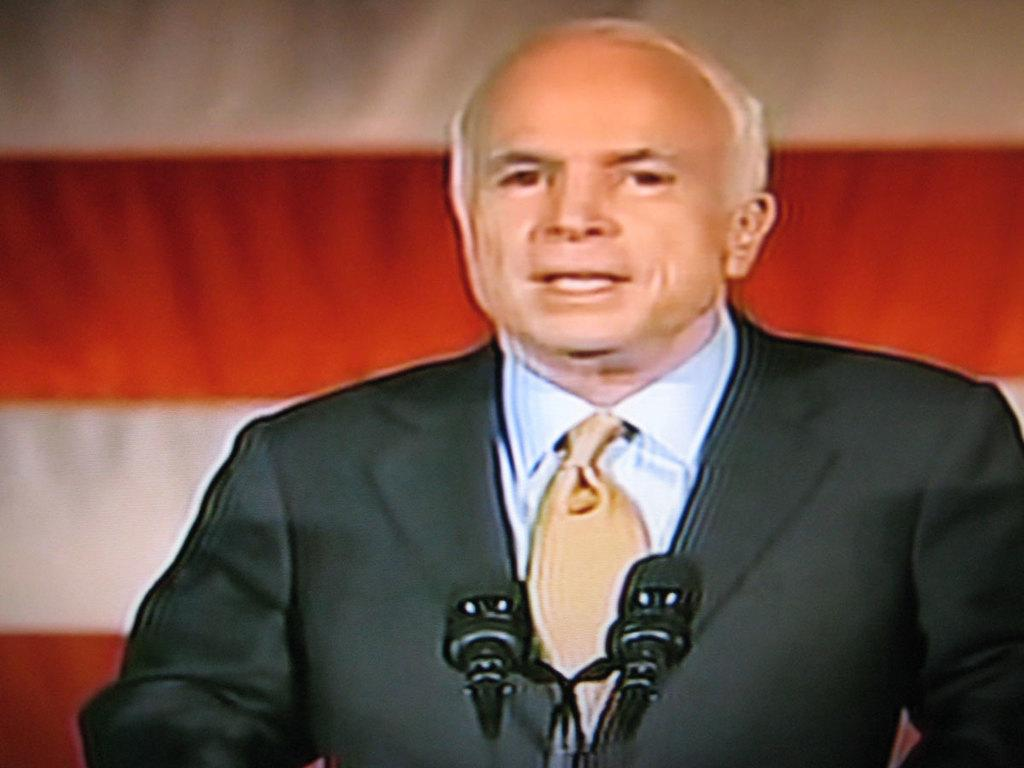Who is present in the image? There is a man in the image. What is the man wearing? The man is wearing a suit. What is the man doing in the image? The man is standing in front of microphones. What can be seen in the background of the image? There are cream and red lines in the background of the image. What type of disease can be seen spreading among the birds in the image? There are no birds present in the image, so it is not possible to determine if there is any disease spreading among them. 